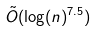<formula> <loc_0><loc_0><loc_500><loc_500>\tilde { O } ( \log ( n ) ^ { 7 . 5 } )</formula> 